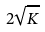<formula> <loc_0><loc_0><loc_500><loc_500>2 \sqrt { K }</formula> 